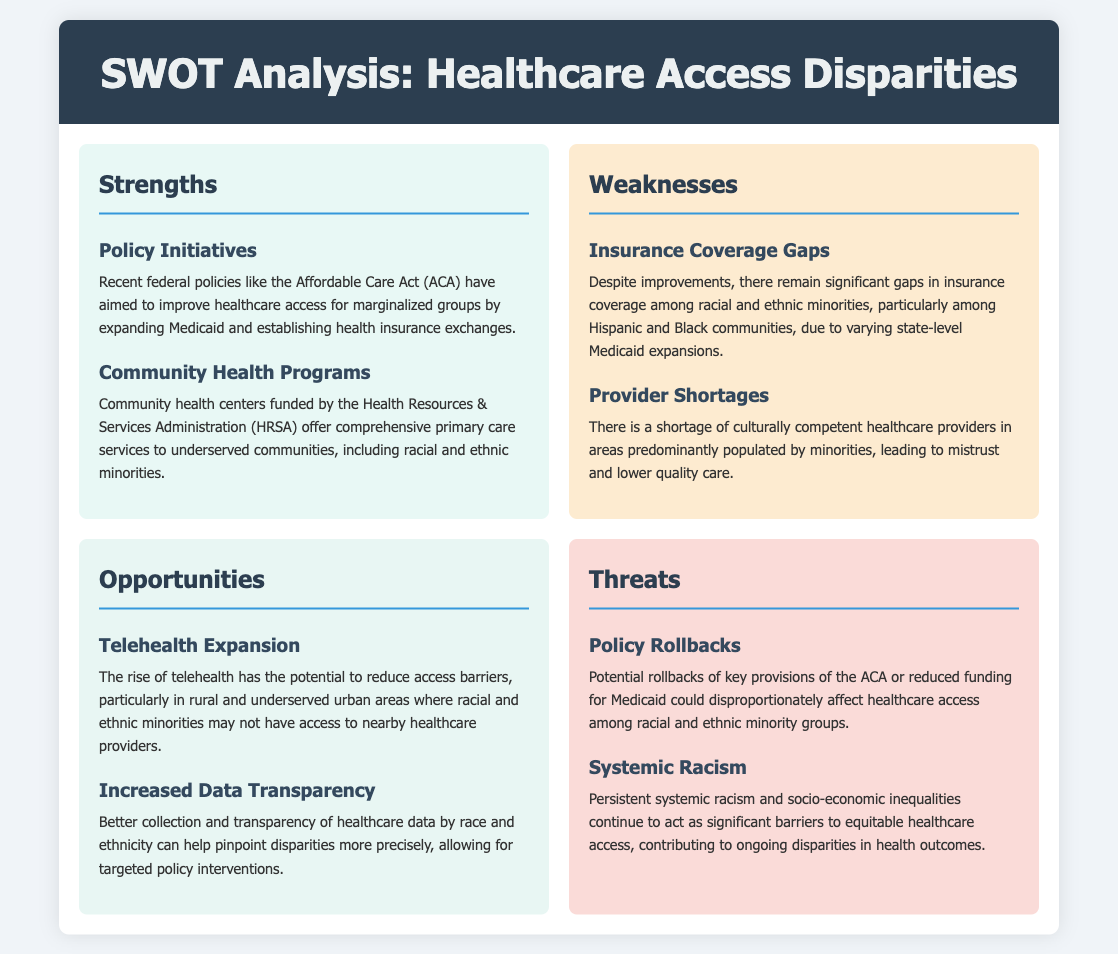What is a recent federal policy aimed at improving healthcare access for marginalized groups? The document mentions the Affordable Care Act (ACA) as a key federal policy designed to enhance healthcare access for marginalized communities.
Answer: Affordable Care Act What do community health centers provide? According to the document, community health centers funded by HRSA offer comprehensive primary care services to underserved communities.
Answer: Comprehensive primary care services Which two racial and ethnic communities are highlighted for having insurance coverage gaps? The document identifies Hispanic and Black communities as facing significant gaps in insurance coverage despite some improvements.
Answer: Hispanic and Black What is a potential opportunity for reducing access barriers mentioned in the document? The SWOT analysis discusses the rise of telehealth as a promising opportunity to mitigate access barriers for underserved populations.
Answer: Telehealth expansion What systemic issue continues to act as a barrier to equitable healthcare access? The document points out persistent systemic racism and socio-economic inequalities as major barriers affecting healthcare access.
Answer: Systemic racism What might threaten healthcare access among racial and ethnic minorities due to policy changes? The SWOT analysis mentions potential rollbacks of key provisions of the ACA as a significant threat to healthcare access for marginalized groups.
Answer: Policy rollbacks What type of data collection can help pinpoint healthcare disparities more precisely? Increased data transparency regarding healthcare by race and ethnicity could improve the identification of health disparities.
Answer: Increased data transparency What organization funds community health programs? The Health Resources & Services Administration (HRSA) is mentioned as the organization funding community health programs for underserved communities.
Answer: Health Resources & Services Administration (HRSA) 